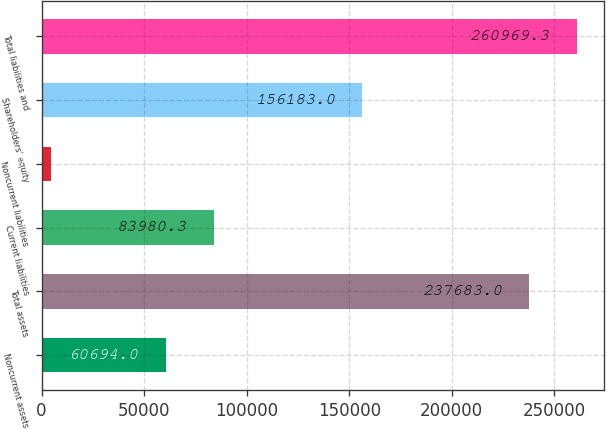<chart> <loc_0><loc_0><loc_500><loc_500><bar_chart><fcel>Noncurrent assets<fcel>Total assets<fcel>Current liabilities<fcel>Noncurrent liabilities<fcel>Shareholders' equity<fcel>Total liabilities and<nl><fcel>60694<fcel>237683<fcel>83980.3<fcel>4820<fcel>156183<fcel>260969<nl></chart> 